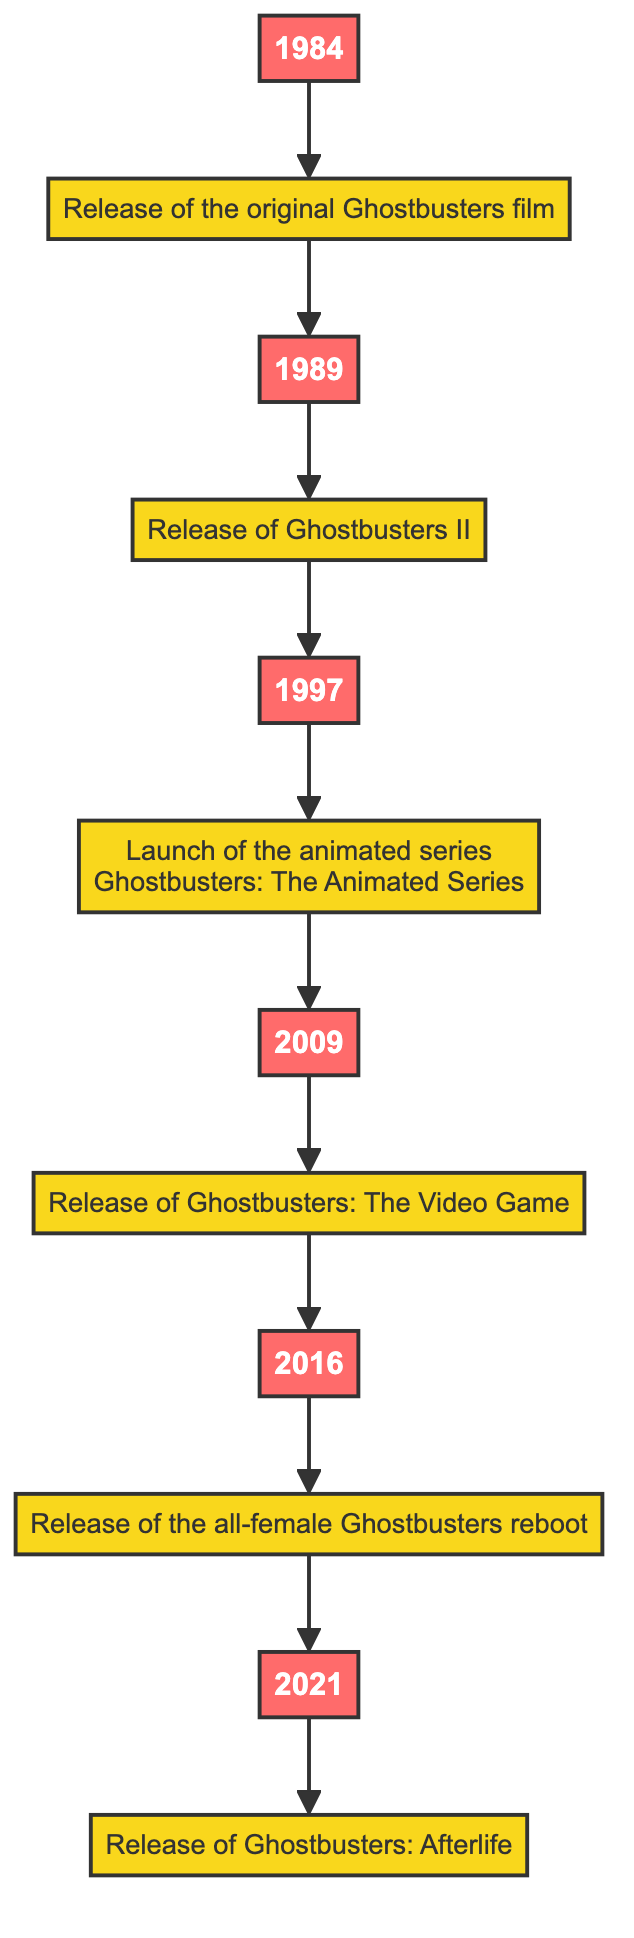What year did the original Ghostbusters film release? The diagram shows that the first event is linked to the year 1984. Therefore, the answer is simply the year indicated.
Answer: 1984 How many major events are depicted in the timeline? By counting the events from the 1984 release up to Ghostbusters: Afterlife in 2021, there are a total of six events illustrated in the flowchart.
Answer: 6 Which film was released after Ghostbusters II? The flowchart indicates that Ghostbusters II was released in 1989 and the next event shown is the launch of the animated series in 1997. Therefore, it directly follows the Ghostbusters II event.
Answer: Launch of the animated series Ghostbusters: The Animated Series What is the last event on the timeline? Looking at the end of the flowchart, the final event connected to the year 2021 is the release of Ghostbusters: Afterlife. This is the last node we encounter.
Answer: Release of Ghostbusters: Afterlife Which year saw the release of the all-female Ghostbusters reboot? From the flowchart, the event labeled "Release of the all-female Ghostbusters reboot" is connected to the year 2016, showing the timeline sequence of events leading up to that point.
Answer: 2016 What is the chronological order of events from the original Ghostbusters film to Ghostbusters: Afterlife? The flowchart shows a sequence starting from the original Ghostbusters film in 1984, followed by Ghostbusters II in 1989, the animated series in 1997, the video game in 2009, the all-female reboot in 2016, and ending with Ghostbusters: Afterlife in 2021, effectively making a complete list of events in order.
Answer: 1984, 1989, 1997, 2009, 2016, 2021 How many years apart were Ghostbusters II and Ghostbusters: The Video Game? By looking at the years in the diagram, Ghostbusters II was released in 1989, and Ghostbusters: The Video Game was released in 2009. The difference is calculated by subtracting these years, which is 2009 - 1989 = 20 years.
Answer: 20 years Which event directly follows the launch of The Animated Series? The flowchart showcases that after the animated series launched in 1997, the next event is connected to the year 2009, which corresponds to the video game release; thus, it is the immediate next event in the timeline.
Answer: Release of Ghostbusters: The Video Game 